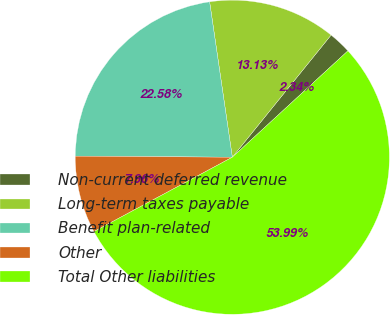Convert chart. <chart><loc_0><loc_0><loc_500><loc_500><pie_chart><fcel>Non-current deferred revenue<fcel>Long-term taxes payable<fcel>Benefit plan-related<fcel>Other<fcel>Total Other liabilities<nl><fcel>2.34%<fcel>13.13%<fcel>22.58%<fcel>7.96%<fcel>53.99%<nl></chart> 